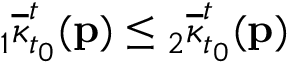Convert formula to latex. <formula><loc_0><loc_0><loc_500><loc_500>{ } _ { 1 } \overline { \kappa } _ { t _ { 0 } } ^ { t } ( p ) _ { 2 } \overline { \kappa } _ { t _ { 0 } } ^ { t } ( p )</formula> 